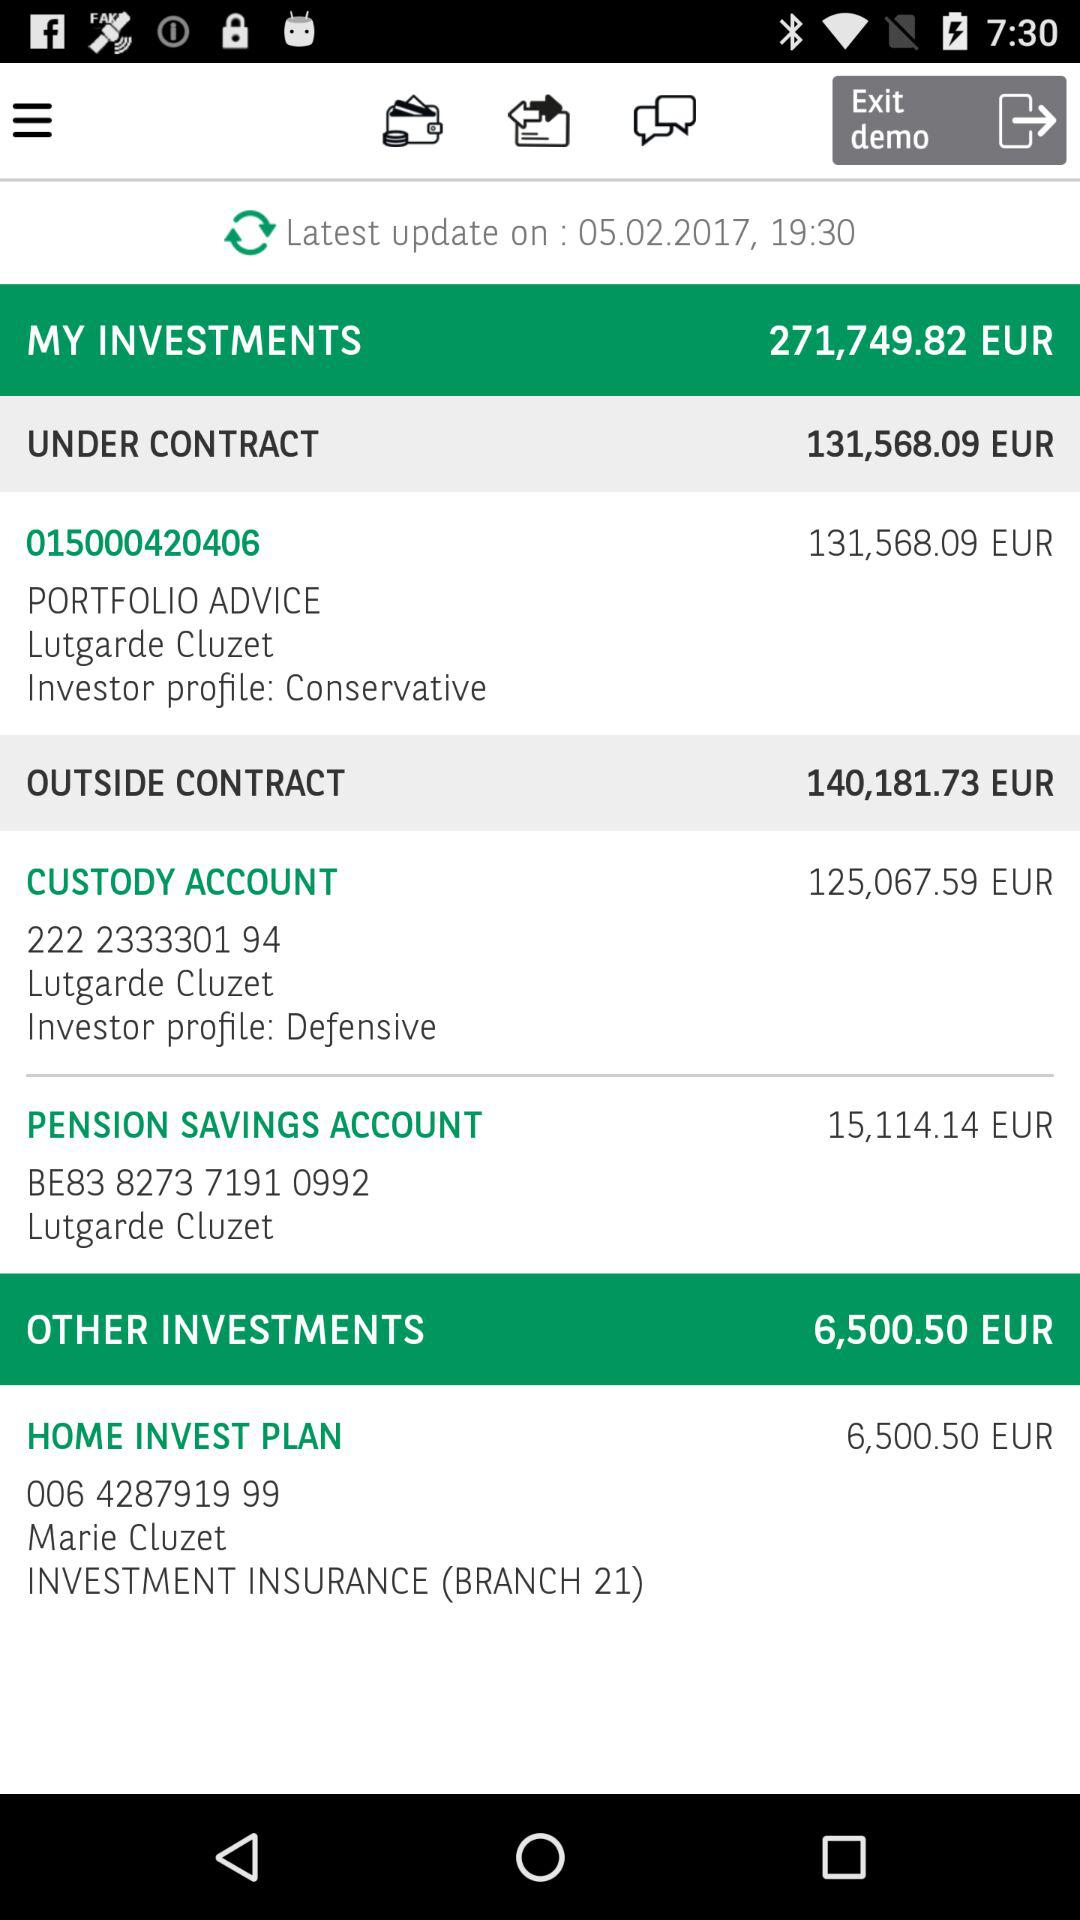What is the total amount of money invested in all portfolios?
Answer the question using a single word or phrase. 271,749.82 EUR 